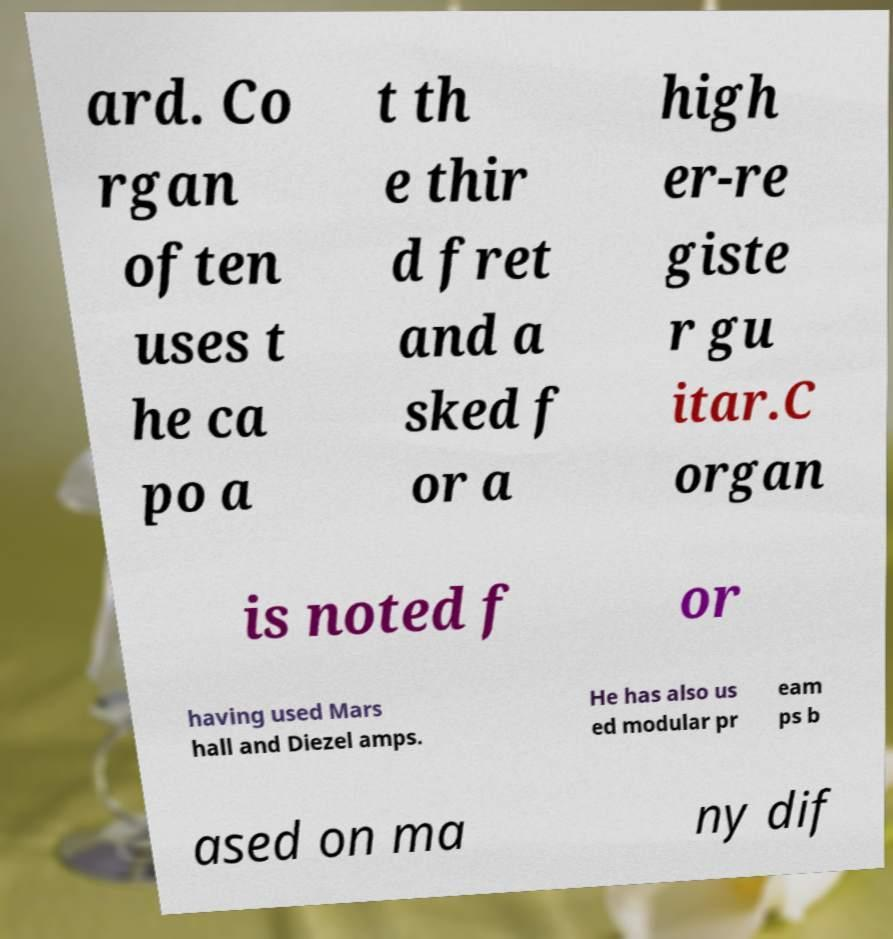Can you accurately transcribe the text from the provided image for me? ard. Co rgan often uses t he ca po a t th e thir d fret and a sked f or a high er-re giste r gu itar.C organ is noted f or having used Mars hall and Diezel amps. He has also us ed modular pr eam ps b ased on ma ny dif 